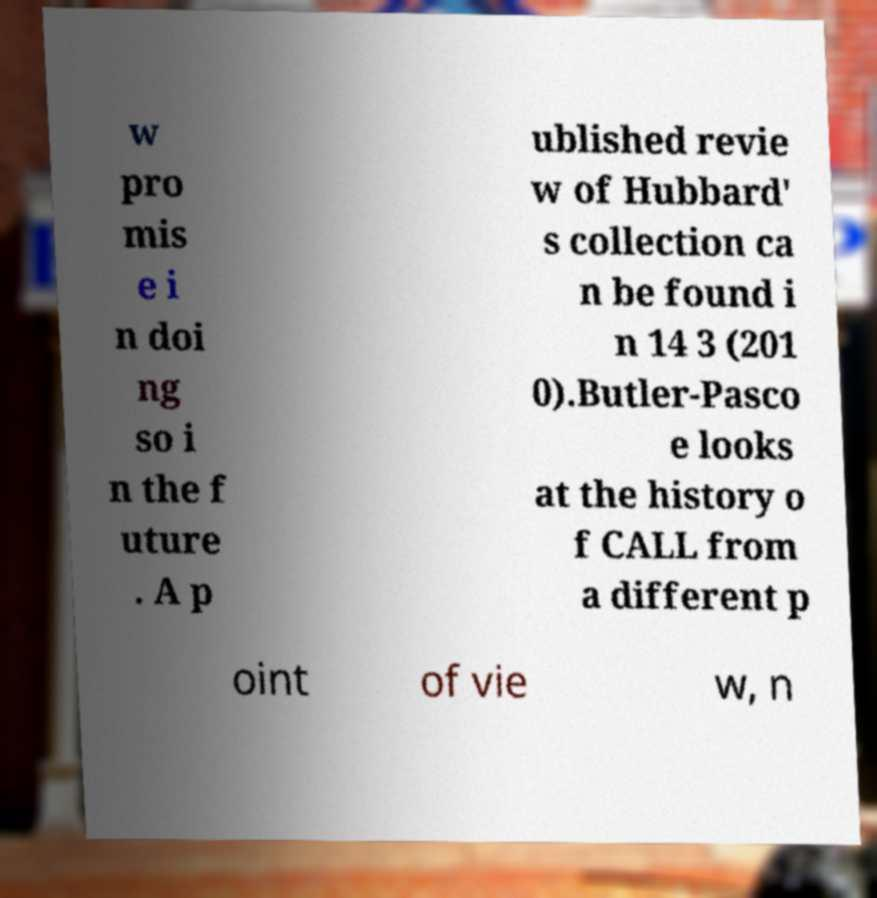Please identify and transcribe the text found in this image. w pro mis e i n doi ng so i n the f uture . A p ublished revie w of Hubbard' s collection ca n be found i n 14 3 (201 0).Butler-Pasco e looks at the history o f CALL from a different p oint of vie w, n 